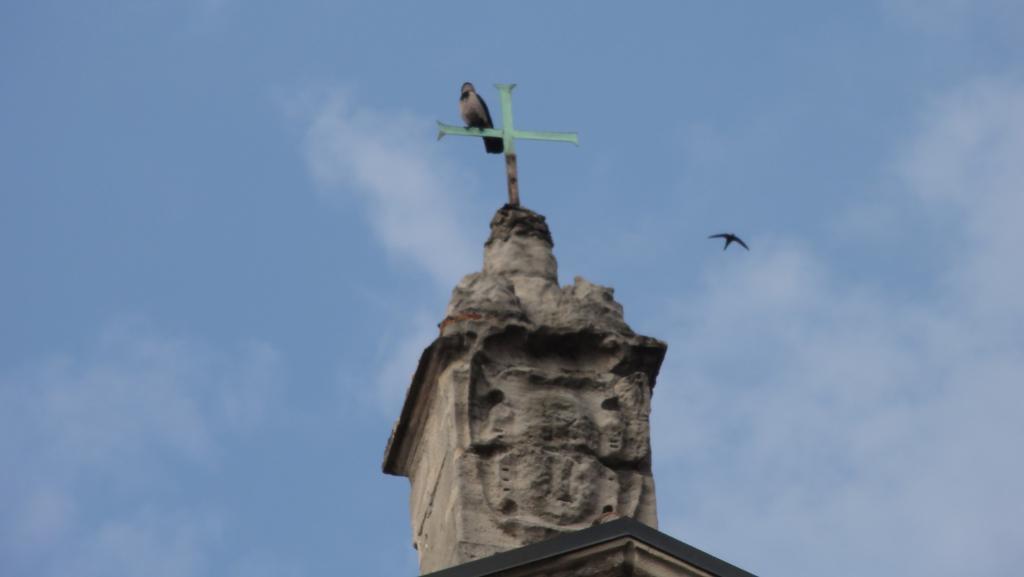Could you give a brief overview of what you see in this image? In the middle of the image there is a statue, on the statue there is a bird. Behind the statue there are some clouds and sky and there is a bird flying. 